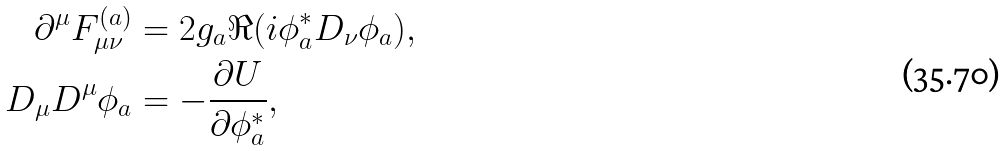Convert formula to latex. <formula><loc_0><loc_0><loc_500><loc_500>\partial ^ { \mu } F ^ { ( a ) } _ { \mu \nu } & = 2 g _ { a } \Re ( i \phi ^ { \ast } _ { a } D _ { \nu } \phi _ { a } ) , \\ D _ { \mu } D ^ { \mu } \phi _ { a } & = - \frac { \partial U } { \partial \phi _ { a } ^ { \ast } } ,</formula> 